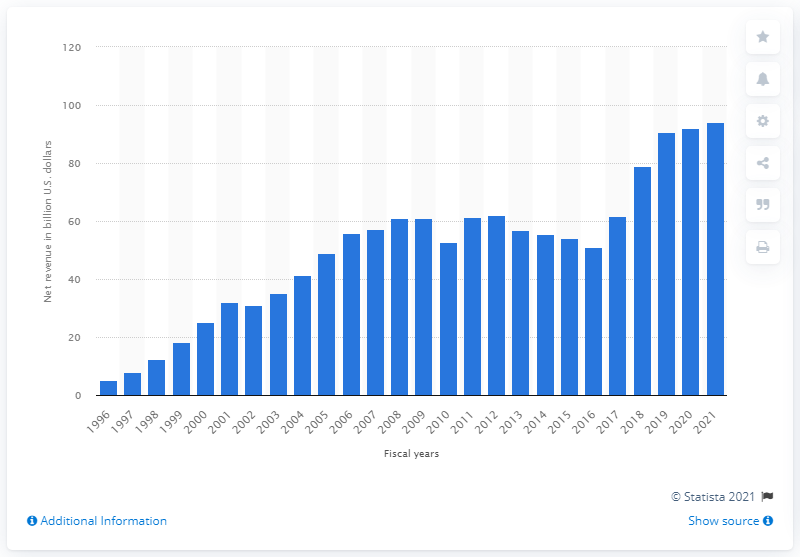Indicate a few pertinent items in this graphic. In the 2021 fiscal year, the revenue of Dell Technologies was 94.22 billion dollars. 